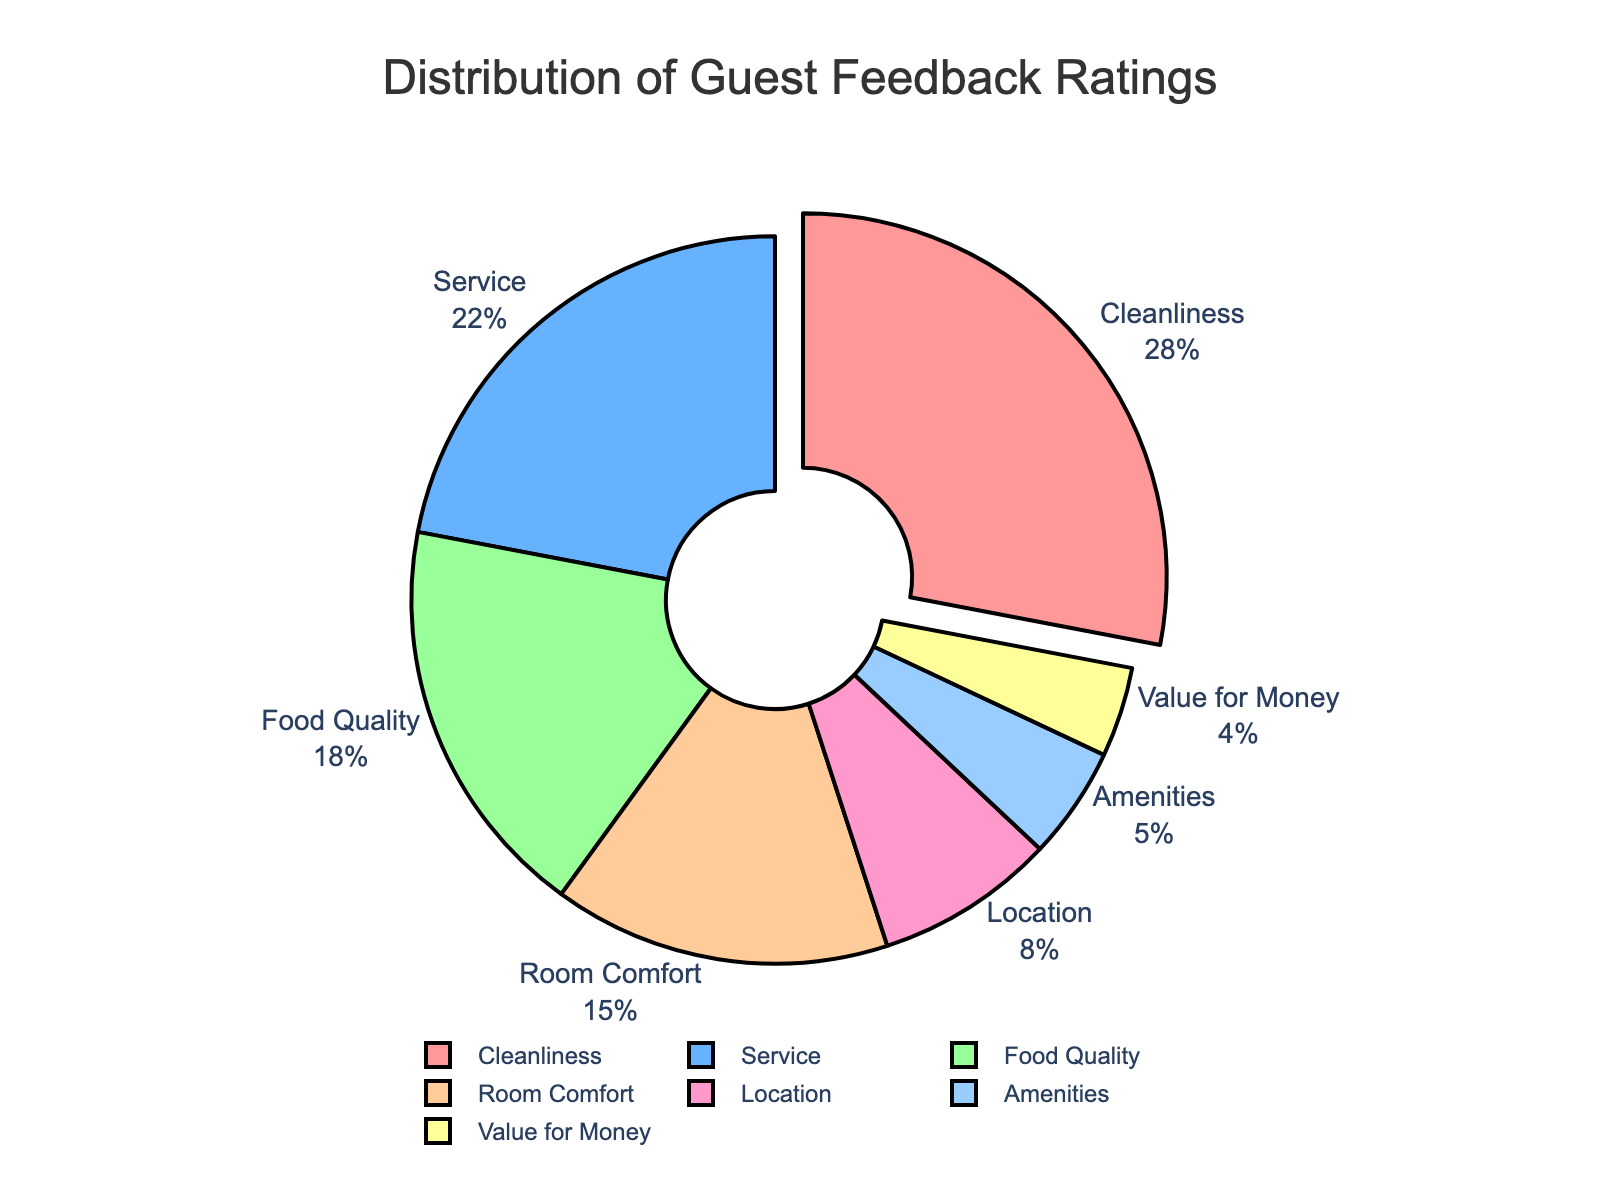What aspect received the highest percentage of guest feedback? The cleanliness aspect received the highest percentage of guest feedback at 28%. This is evident from the pie chart where the cleanliness segment is pulled out, indicating it received the highest percentage.
Answer: Cleanliness How much higher is the feedback percentage for cleanliness compared to service? Cleanliness has a feedback percentage of 28% while service has 22%. The difference between them is 28% - 22%.
Answer: 6% Which aspects have a feedback percentage less than 10%? The aspects with a feedback percentage less than 10% are Location (8%), Amenities (5%), and Value for Money (4%). This is indicated by the relatively smaller segments in the pie chart.
Answer: Location, Amenities, and Value for Money What is the total percentage of guest feedback for amenities and value for money combined? Adding the percentages for amenities (5%) and value for money (4%) gives 5% + 4%.
Answer: 9% Are there more guest feedback ratings for room comfort or for food quality? Food quality has a feedback percentage of 18%, whereas room comfort has 15%. Since 18% is greater than 15%, food quality has more guest feedback ratings.
Answer: Food Quality What percentage of guest feedback is given for aspects other than cleanliness, service, and food quality? The percentages for cleanliness, service, and food quality are 28%, 22%, and 18%, respectively. Adding these gives 28% + 22% + 18% = 68%. Therefore, the feedback for other aspects is 100% - 68%.
Answer: 32% Which aspect has the smallest percentage of guest feedback, and what is that percentage? The aspect with the smallest percentage of guest feedback is Value for Money with 4%. This is reflected in the smallest segment in the pie chart.
Answer: Value for Money, 4% How does the visual representation indicate the aspect with the highest feedback percentage? The cleanliness segment is slightly pulled out from the rest of the pie chart, making it visually distinct and indicating that it has the highest feedback percentage.
Answer: Pulled out segment for Cleanliness Compare the combined percentage of feedback for service and room comfort with that for cleanliness. Which is higher? Service and room comfort have percentages of 22% and 15%, respectively. Combined, they add up to 22% + 15% = 37%. Cleanliness alone has 28%. Since 37% is higher than 28%, service and room comfort combined have a higher percentage.
Answer: Service and Room Comfort combined What is the average feedback percentage for cleanliness, service, and food quality? The percentages for cleanliness, service, and food quality are 28%, 22%, and 18%, respectively. Their total is 28% + 22% + 18% = 68%. The average is obtained by dividing this total by the number of aspects, which is 3, so 68% / 3.
Answer: 22.67% 